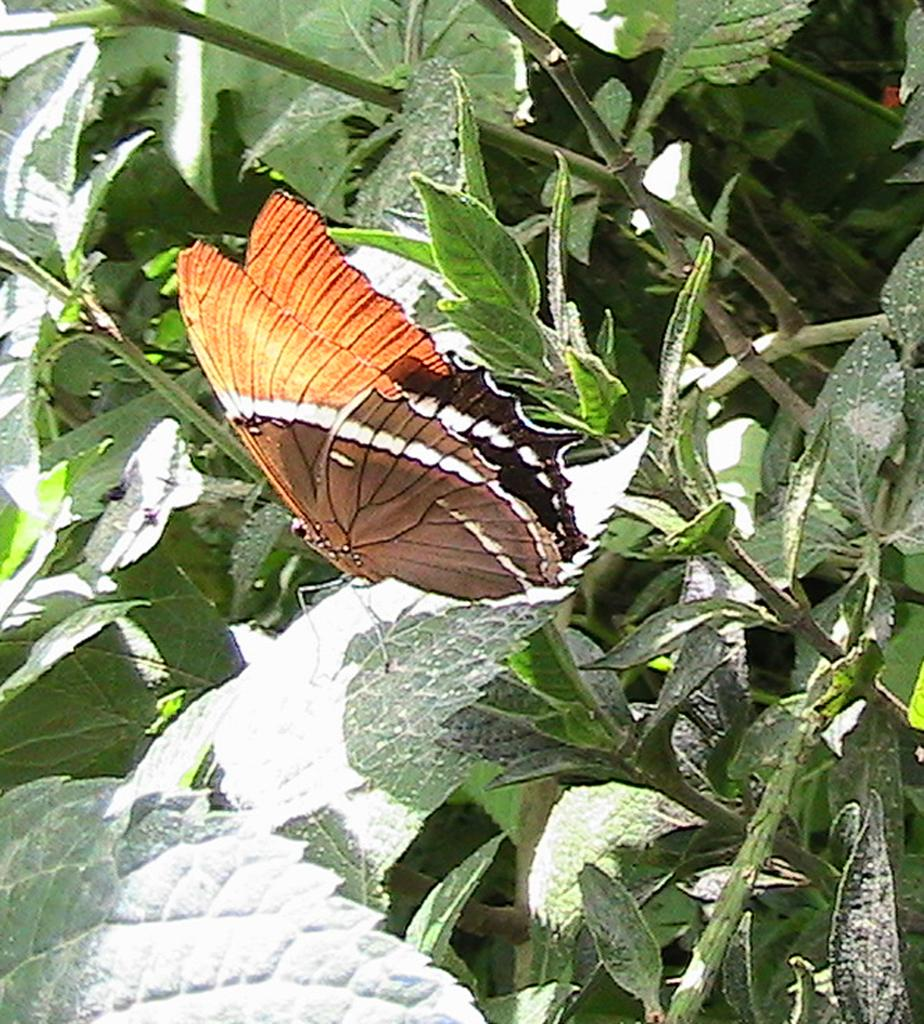What is the main subject of the picture? The main subject of the picture is a butterfly. Where is the butterfly located in the image? The butterfly is standing on a leaf. What can be seen in the background of the image? There are plants visible in the background of the image. What is present at the bottom of the image? There are many leaves at the bottom of the image. What color is the scarf worn by the woman in the image? There are no women or scarves present in the image; it features a butterfly standing on a leaf. 